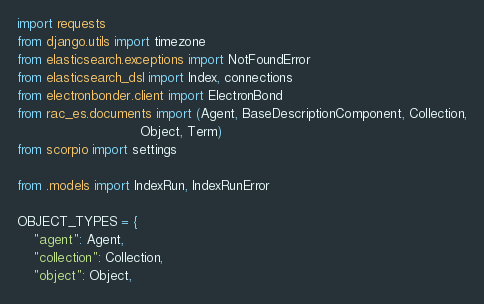<code> <loc_0><loc_0><loc_500><loc_500><_Python_>import requests
from django.utils import timezone
from elasticsearch.exceptions import NotFoundError
from elasticsearch_dsl import Index, connections
from electronbonder.client import ElectronBond
from rac_es.documents import (Agent, BaseDescriptionComponent, Collection,
                              Object, Term)
from scorpio import settings

from .models import IndexRun, IndexRunError

OBJECT_TYPES = {
    "agent": Agent,
    "collection": Collection,
    "object": Object,</code> 